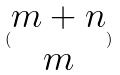<formula> <loc_0><loc_0><loc_500><loc_500>( \begin{matrix} m + n \\ m \end{matrix} )</formula> 